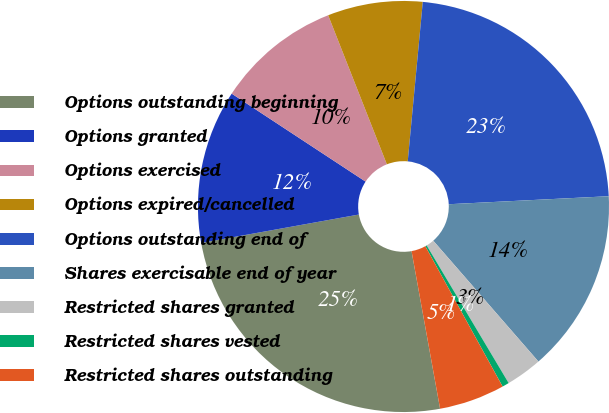Convert chart. <chart><loc_0><loc_0><loc_500><loc_500><pie_chart><fcel>Options outstanding beginning<fcel>Options granted<fcel>Options exercised<fcel>Options expired/cancelled<fcel>Options outstanding end of<fcel>Shares exercisable end of year<fcel>Restricted shares granted<fcel>Restricted shares vested<fcel>Restricted shares outstanding<nl><fcel>25.02%<fcel>12.09%<fcel>9.78%<fcel>7.47%<fcel>22.71%<fcel>14.4%<fcel>2.85%<fcel>0.54%<fcel>5.16%<nl></chart> 